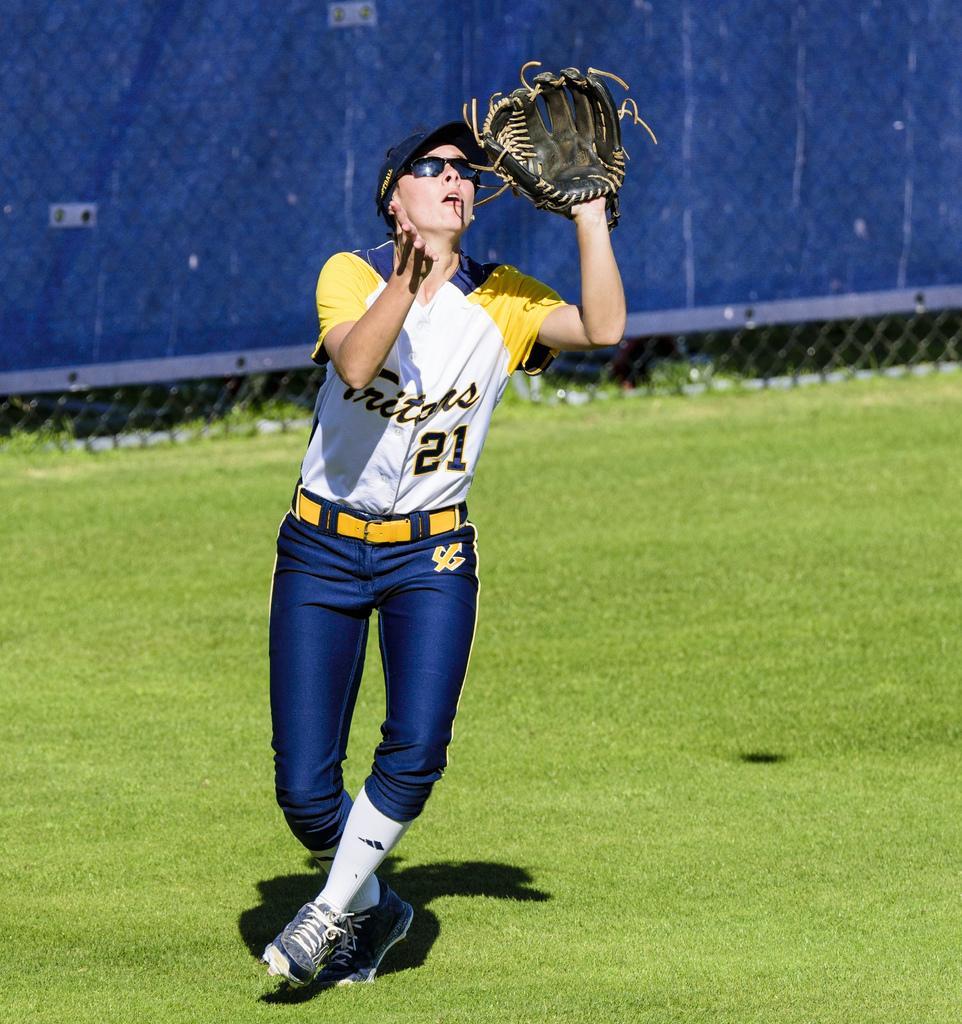Describe this image in one or two sentences. In the image I can see a person who is wearing the gloves, spectacles and hat and behind there is a fencing. 